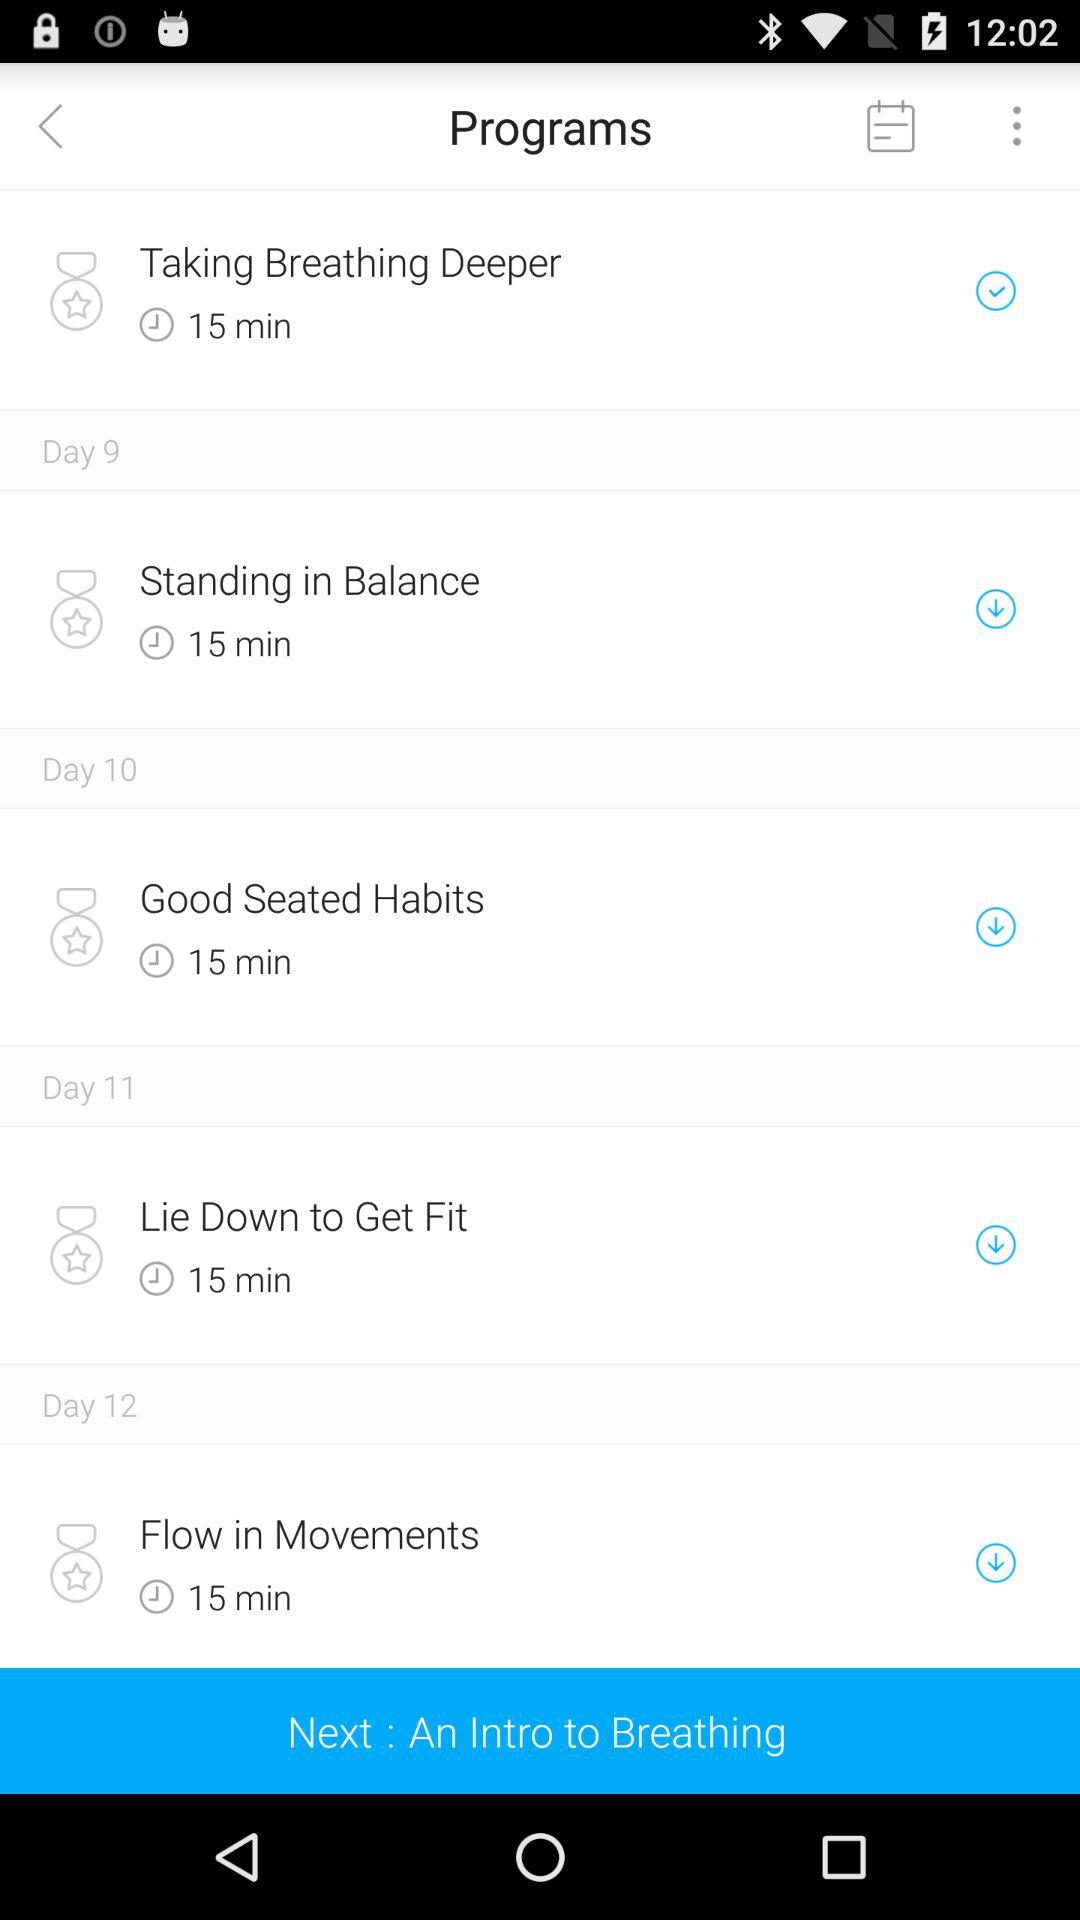How long is the program "Taking Breathing Deeper"? The program "Taking Breathing Deeper" is 15 minutes long. 